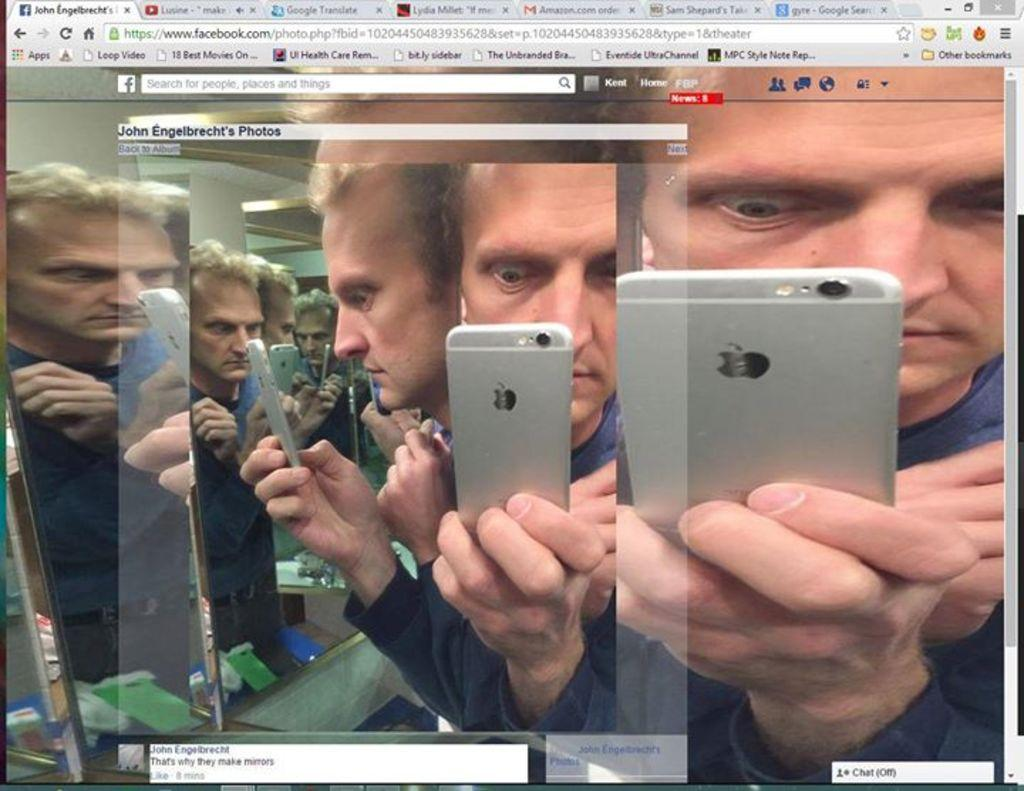What is the main object in the image? There is a screen in the image. What can be seen on the screen? A person is visible on the screen. What is the person holding in his hand? The person is holding a mobile with his hand. What type of vegetable is the person holding in his hand? There is no vegetable present in the image; the person is holding a mobile. What color is the yarn that the person is using to knit in the image? There is no yarn or knitting activity present in the image. 